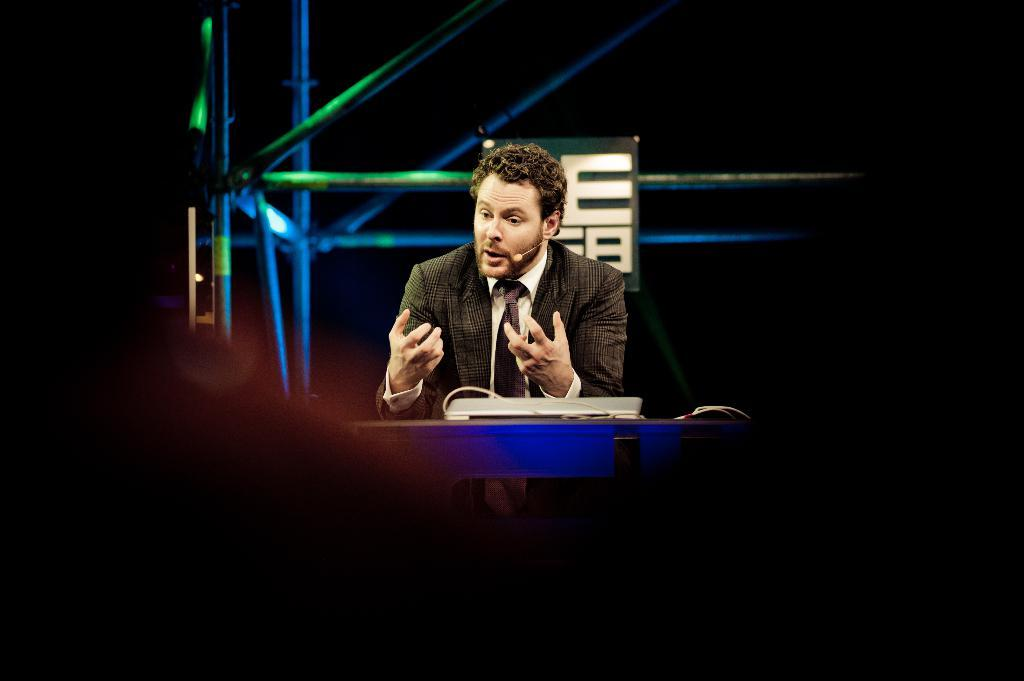What is the main subject of the image? The main subject of the image is a man. What is the man wearing in the image? The man is wearing a blazer and a tie. What is the man doing in the image? The man is speaking on a microphone. What object is in front of the man? There is a laptop in front of the man. What can be seen in the background of the image? The background of the image is dark, and there are rods visible. What type of design can be seen on the man's collar in the image? There is no collar visible in the image, as the man is wearing a blazer and tie. How long has the man been sleeping in the image? There is no indication that the man is sleeping in the image; he is speaking on a microphone. 